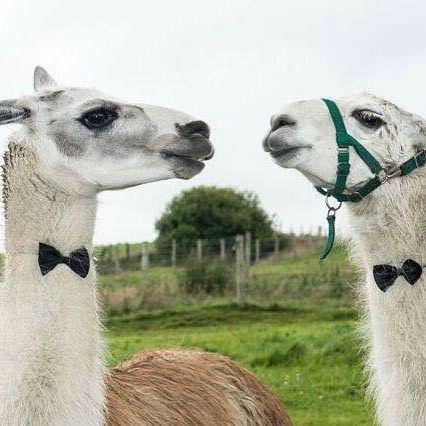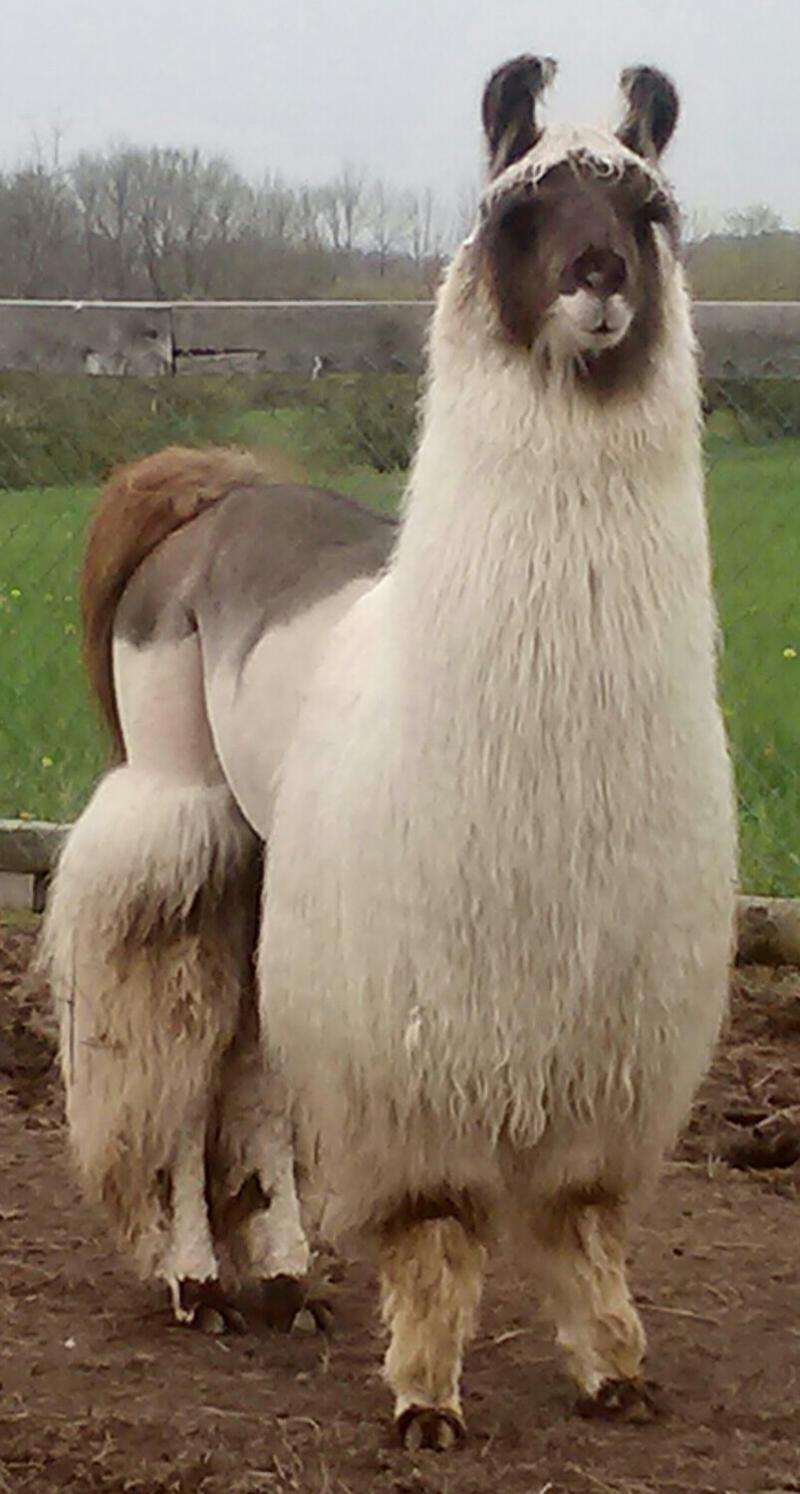The first image is the image on the left, the second image is the image on the right. Analyze the images presented: Is the assertion "Each llama in the pair of images is an adult llama." valid? Answer yes or no. Yes. The first image is the image on the left, the second image is the image on the right. Examine the images to the left and right. Is the description "There are two llamas in the left image and one llama in the right image." accurate? Answer yes or no. Yes. 